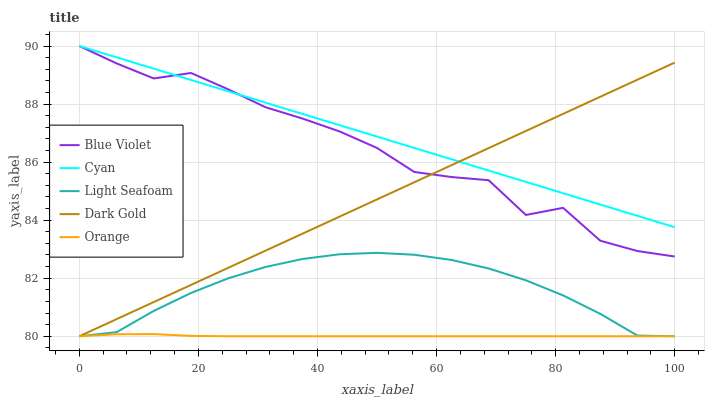Does Orange have the minimum area under the curve?
Answer yes or no. Yes. Does Cyan have the maximum area under the curve?
Answer yes or no. Yes. Does Light Seafoam have the minimum area under the curve?
Answer yes or no. No. Does Light Seafoam have the maximum area under the curve?
Answer yes or no. No. Is Cyan the smoothest?
Answer yes or no. Yes. Is Blue Violet the roughest?
Answer yes or no. Yes. Is Light Seafoam the smoothest?
Answer yes or no. No. Is Light Seafoam the roughest?
Answer yes or no. No. Does Orange have the lowest value?
Answer yes or no. Yes. Does Cyan have the lowest value?
Answer yes or no. No. Does Blue Violet have the highest value?
Answer yes or no. Yes. Does Light Seafoam have the highest value?
Answer yes or no. No. Is Orange less than Blue Violet?
Answer yes or no. Yes. Is Blue Violet greater than Light Seafoam?
Answer yes or no. Yes. Does Dark Gold intersect Cyan?
Answer yes or no. Yes. Is Dark Gold less than Cyan?
Answer yes or no. No. Is Dark Gold greater than Cyan?
Answer yes or no. No. Does Orange intersect Blue Violet?
Answer yes or no. No. 